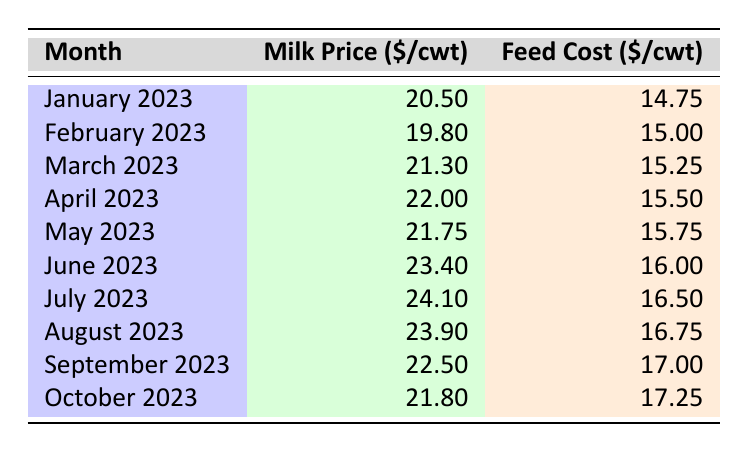What was the milk price in July 2023? According to the table, the milk price in July 2023 is specifically listed as 24.10 dollars per hundredweight (cwt).
Answer: 24.10 What was the feed cost for March 2023? Referring to the table, the feed cost for March 2023 is 15.25 dollars per cwt.
Answer: 15.25 Was the milk price higher in June 2023 than in May 2023? The milk price in June 2023 is 23.40 dollars per cwt, and in May 2023 it is 21.75 dollars per cwt. Since 23.40 is greater than 21.75, the statement is true.
Answer: Yes What is the difference between the milk price in January 2023 and the milk price in October 2023? The milk price in January 2023 is 20.50 dollars per cwt, and the price in October 2023 is 21.80 dollars per cwt. The difference is 21.80 - 20.50 = 1.30 dollars.
Answer: 1.30 What was the average feed cost for the months of June, July, and August 2023? The feed costs for June, July, and August are 16.00, 16.50, and 16.75 dollars per cwt, respectively. First, sum these values: 16.00 + 16.50 + 16.75 = 49.25. Then, divide by 3 to find the average: 49.25 / 3 = 16.4167, which rounds to approximately 16.42 dollars.
Answer: 16.42 Was there any month when the feed cost was equal to 15 dollars or less? By examining the table, the feed costs start from 14.75 dollars in January 2023 and increase thereafter. Therefore, there was one month where the feed cost was equal to or less than 15 dollars (January 2023).
Answer: Yes Which month had the highest feed cost? The highest feed cost value in the table is 17.25 dollars per cwt, which occurred in October 2023.
Answer: October 2023 What is the total sum of milk prices from January to October 2023? Adding the monthly milk prices: 20.50 + 19.80 + 21.30 + 22.00 + 21.75 + 23.40 + 24.10 + 23.90 + 22.50 + 21.80 =  220.55 dollars.
Answer: 220.55 What was the trend in milk prices from January 2023 to October 2023? Observing the milk prices listed in the table, they generally increased from January to July, peaked in July, then gradually decreased until October. This indicates a fluctuation pattern with an overall decrease after the mid-year peak.
Answer: Fluctuation with a peak in July 